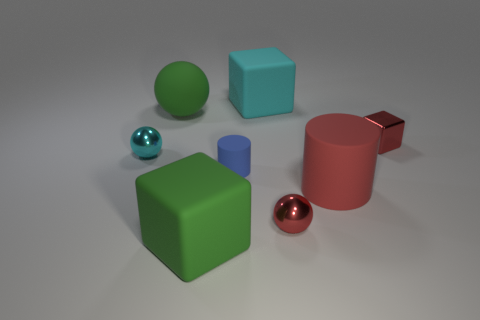Add 1 large green rubber cylinders. How many objects exist? 9 Subtract all cubes. How many objects are left? 5 Subtract 0 gray balls. How many objects are left? 8 Subtract all gray metallic cylinders. Subtract all tiny rubber objects. How many objects are left? 7 Add 8 green matte blocks. How many green matte blocks are left? 9 Add 8 small blue rubber balls. How many small blue rubber balls exist? 8 